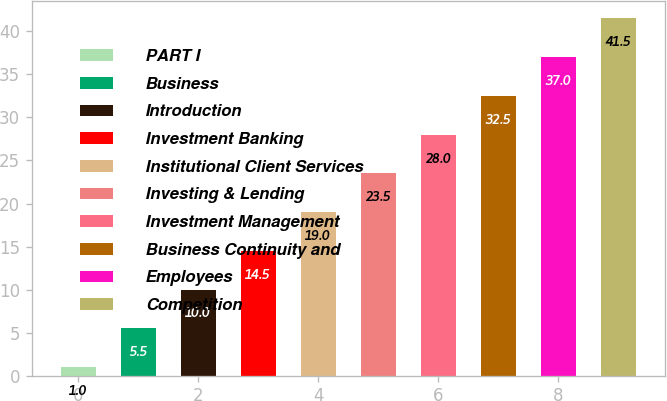Convert chart to OTSL. <chart><loc_0><loc_0><loc_500><loc_500><bar_chart><fcel>PART I<fcel>Business<fcel>Introduction<fcel>Investment Banking<fcel>Institutional Client Services<fcel>Investing & Lending<fcel>Investment Management<fcel>Business Continuity and<fcel>Employees<fcel>Competition<nl><fcel>1<fcel>5.5<fcel>10<fcel>14.5<fcel>19<fcel>23.5<fcel>28<fcel>32.5<fcel>37<fcel>41.5<nl></chart> 